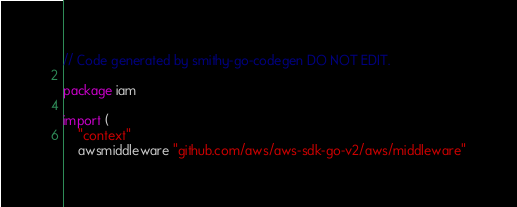Convert code to text. <code><loc_0><loc_0><loc_500><loc_500><_Go_>// Code generated by smithy-go-codegen DO NOT EDIT.

package iam

import (
	"context"
	awsmiddleware "github.com/aws/aws-sdk-go-v2/aws/middleware"</code> 